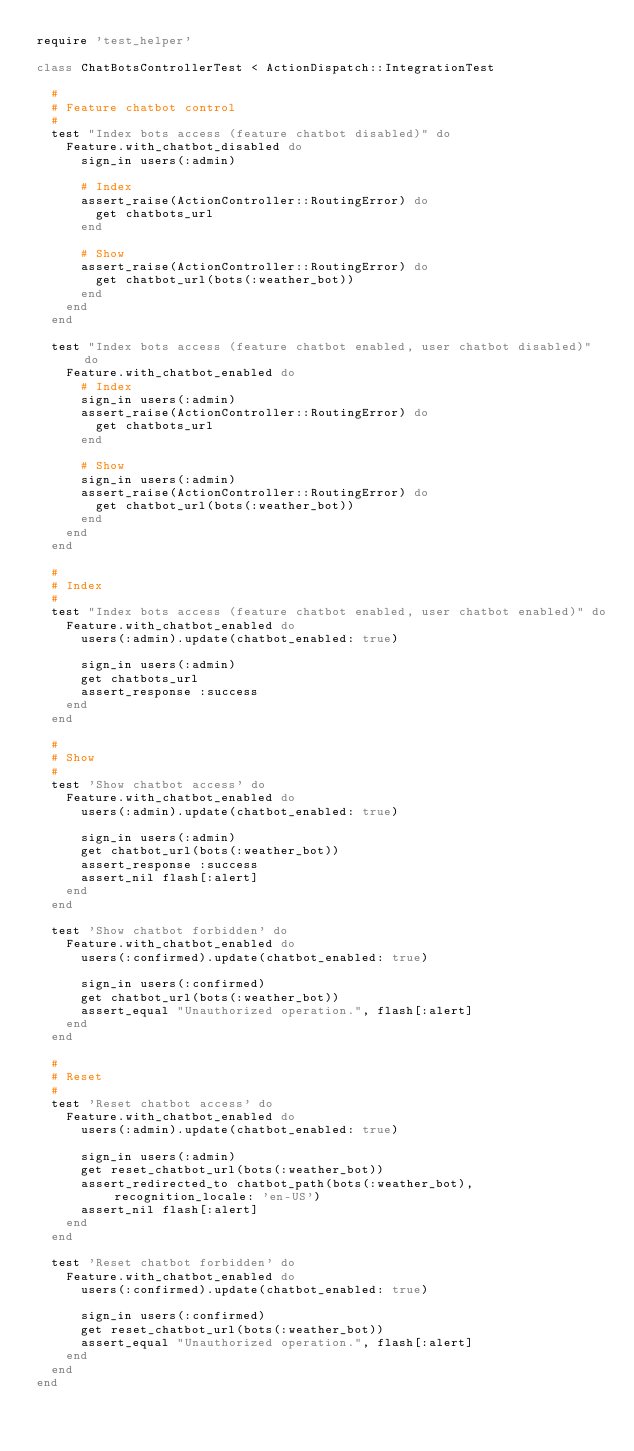Convert code to text. <code><loc_0><loc_0><loc_500><loc_500><_Ruby_>require 'test_helper'

class ChatBotsControllerTest < ActionDispatch::IntegrationTest

  #
  # Feature chatbot control
  #
  test "Index bots access (feature chatbot disabled)" do
    Feature.with_chatbot_disabled do
      sign_in users(:admin)

      # Index
      assert_raise(ActionController::RoutingError) do
        get chatbots_url
      end

      # Show
      assert_raise(ActionController::RoutingError) do
        get chatbot_url(bots(:weather_bot))
      end
    end
  end

  test "Index bots access (feature chatbot enabled, user chatbot disabled)" do
    Feature.with_chatbot_enabled do
      # Index
      sign_in users(:admin)
      assert_raise(ActionController::RoutingError) do
        get chatbots_url
      end

      # Show
      sign_in users(:admin)
      assert_raise(ActionController::RoutingError) do
        get chatbot_url(bots(:weather_bot))
      end
    end
  end

  #
  # Index
  #
  test "Index bots access (feature chatbot enabled, user chatbot enabled)" do
    Feature.with_chatbot_enabled do
      users(:admin).update(chatbot_enabled: true)

      sign_in users(:admin)
      get chatbots_url
      assert_response :success
    end
  end

  #
  # Show
  #
  test 'Show chatbot access' do
    Feature.with_chatbot_enabled do
      users(:admin).update(chatbot_enabled: true)

      sign_in users(:admin)
      get chatbot_url(bots(:weather_bot))
      assert_response :success
      assert_nil flash[:alert]
    end
  end

  test 'Show chatbot forbidden' do
    Feature.with_chatbot_enabled do
      users(:confirmed).update(chatbot_enabled: true)

      sign_in users(:confirmed)
      get chatbot_url(bots(:weather_bot))
      assert_equal "Unauthorized operation.", flash[:alert]
    end
  end

  #
  # Reset
  #
  test 'Reset chatbot access' do
    Feature.with_chatbot_enabled do
      users(:admin).update(chatbot_enabled: true)

      sign_in users(:admin)
      get reset_chatbot_url(bots(:weather_bot))
      assert_redirected_to chatbot_path(bots(:weather_bot), recognition_locale: 'en-US')
      assert_nil flash[:alert]
    end
  end

  test 'Reset chatbot forbidden' do
    Feature.with_chatbot_enabled do
      users(:confirmed).update(chatbot_enabled: true)

      sign_in users(:confirmed)
      get reset_chatbot_url(bots(:weather_bot))
      assert_equal "Unauthorized operation.", flash[:alert]
    end
  end
end
</code> 